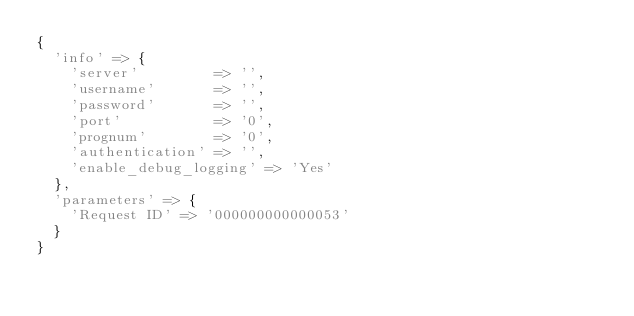Convert code to text. <code><loc_0><loc_0><loc_500><loc_500><_Ruby_>{
  'info' => {
    'server'         => '',
    'username'       => '',
    'password'       => '',
    'port'           => '0',
    'prognum'        => '0',
    'authentication' => '',
    'enable_debug_logging' => 'Yes'
  },
  'parameters' => {
    'Request ID' => '000000000000053'
  } 
}</code> 